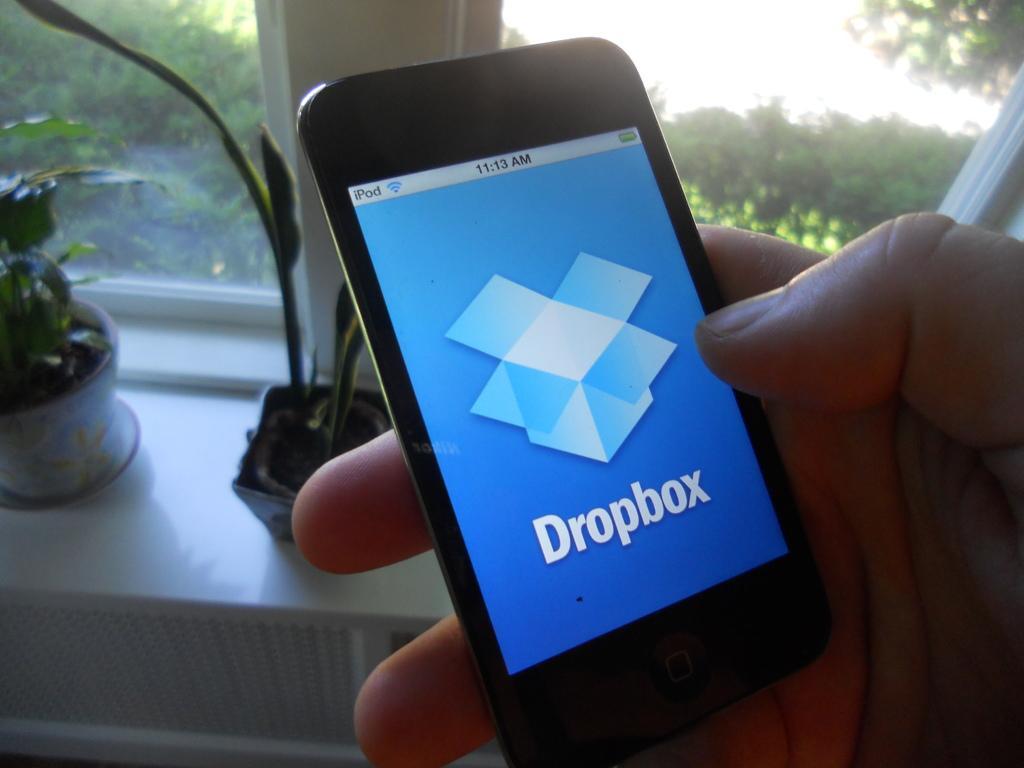How would you summarize this image in a sentence or two? In this picture we can see a person holding a mobile, only person hand is visible. Behind the mobile there are house plants and a glass window. 